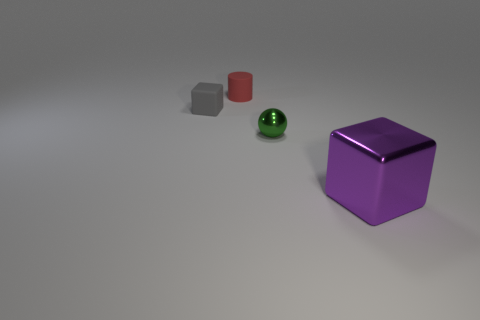Is the shape of the green shiny object the same as the thing that is in front of the small ball?
Give a very brief answer. No. Is there any other thing that has the same color as the tiny matte block?
Provide a succinct answer. No. There is a matte object to the left of the red rubber object; is its color the same as the metal object that is to the left of the big block?
Offer a terse response. No. Are any tiny blue objects visible?
Offer a terse response. No. Are there any red objects that have the same material as the purple object?
Provide a short and direct response. No. Is there any other thing that is made of the same material as the purple thing?
Keep it short and to the point. Yes. The big metallic object is what color?
Provide a succinct answer. Purple. The other rubber object that is the same size as the red thing is what color?
Provide a short and direct response. Gray. How many metal objects are either green balls or big cubes?
Give a very brief answer. 2. How many tiny things are behind the tiny green ball and on the right side of the gray rubber cube?
Ensure brevity in your answer.  1. 